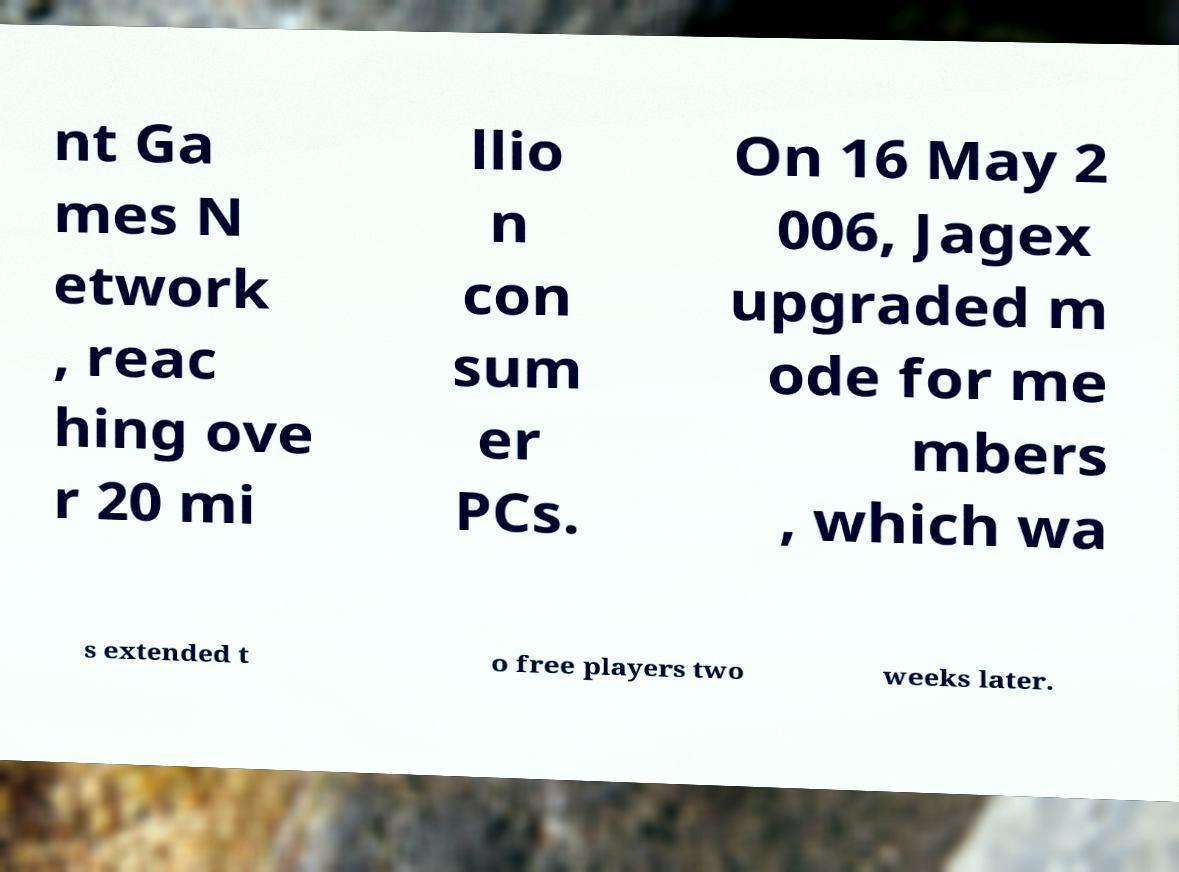Can you read and provide the text displayed in the image?This photo seems to have some interesting text. Can you extract and type it out for me? nt Ga mes N etwork , reac hing ove r 20 mi llio n con sum er PCs. On 16 May 2 006, Jagex upgraded m ode for me mbers , which wa s extended t o free players two weeks later. 